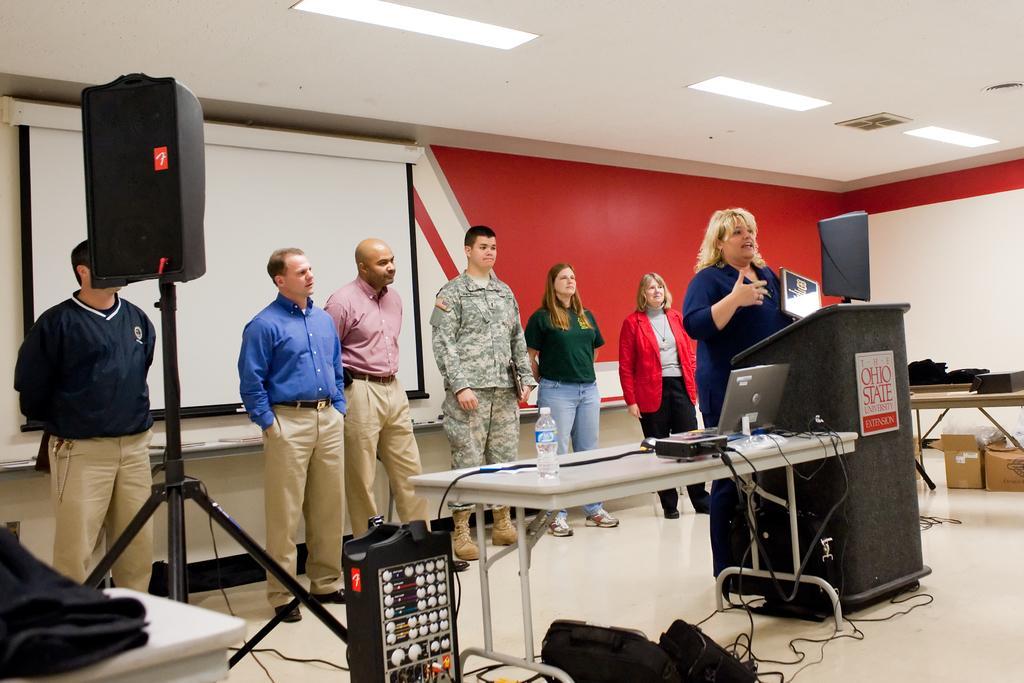Can you describe this image briefly? In the middle of the image, there are seven persons standing. Out of which one woman is standing and talking in front of the standing table. Next to that the table is kept on which laptop and wires are there and a bottle is kept. In the left side of the image, there is a speaker stand. Behind that a screen is there of white in color. A roof top is white in color and a light is mounted on it. Background wall is red in color. In the right middle carton boxes are there on the floor. It looks as if the image is taken inside a office. 